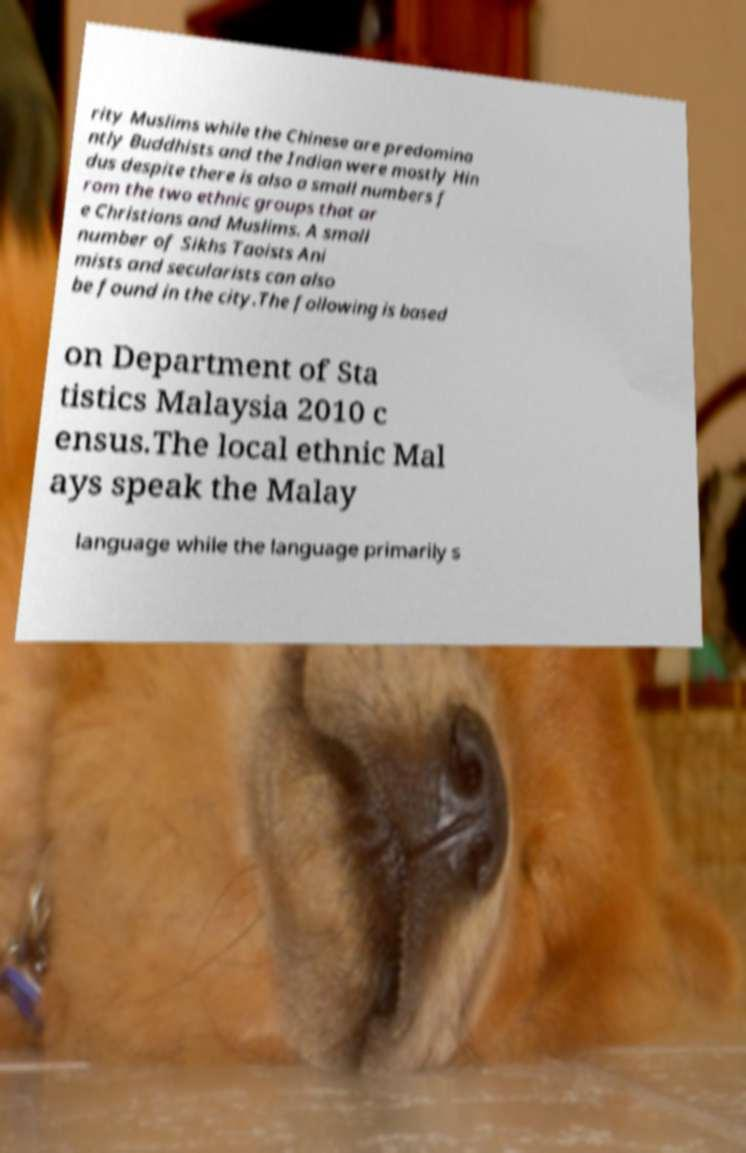I need the written content from this picture converted into text. Can you do that? rity Muslims while the Chinese are predomina ntly Buddhists and the Indian were mostly Hin dus despite there is also a small numbers f rom the two ethnic groups that ar e Christians and Muslims. A small number of Sikhs Taoists Ani mists and secularists can also be found in the city.The following is based on Department of Sta tistics Malaysia 2010 c ensus.The local ethnic Mal ays speak the Malay language while the language primarily s 